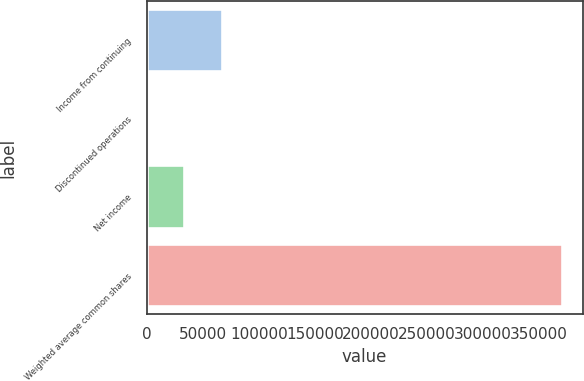Convert chart. <chart><loc_0><loc_0><loc_500><loc_500><bar_chart><fcel>Income from continuing<fcel>Discontinued operations<fcel>Net income<fcel>Weighted average common shares<nl><fcel>67323.4<fcel>33<fcel>33678.2<fcel>370130<nl></chart> 